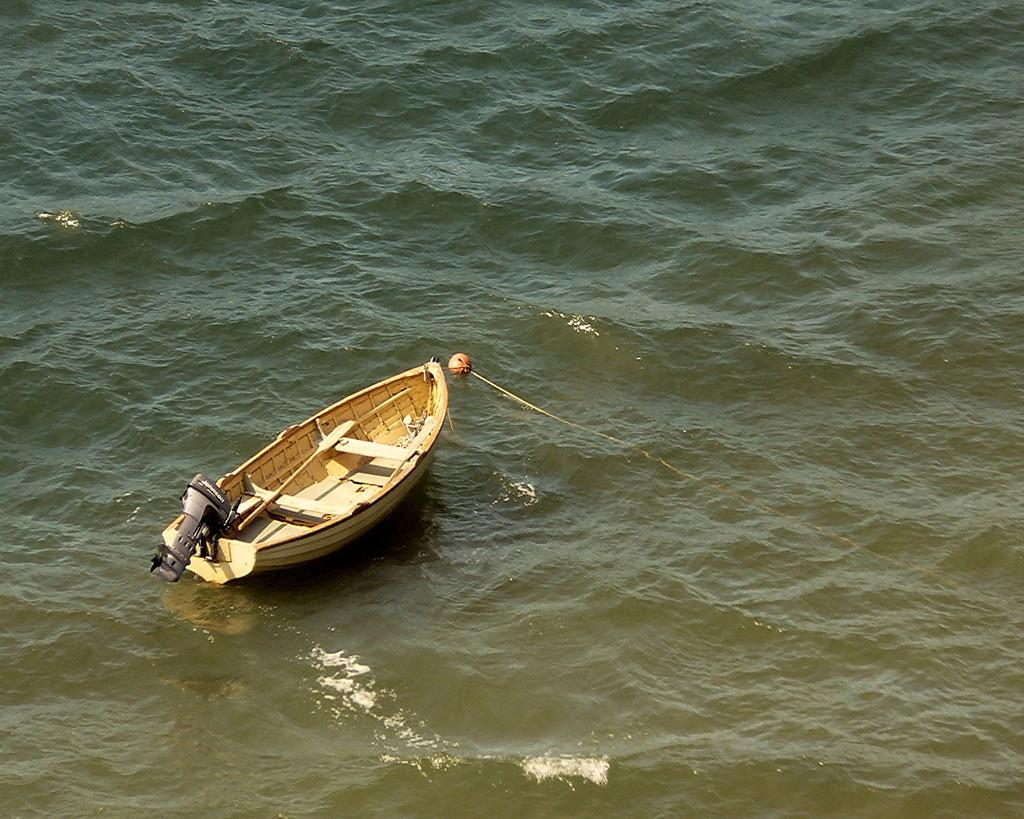What is the main subject of the image? The main subject of the image is a boat. Where is the boat located in the image? The boat is on the water. What type of car can be seen driving on the water in the image? There is no car present in the image; it features a boat on the water. How many geese are swimming alongside the boat in the image? There are no geese present in the image; it only features a boat on the water. 